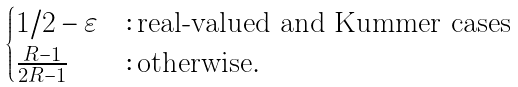<formula> <loc_0><loc_0><loc_500><loc_500>\begin{cases} 1 / 2 - \varepsilon & \colon \text {real-valued and Kummer cases} \\ \frac { R - 1 } { 2 R - 1 } & \colon \text {otherwise} . \end{cases}</formula> 